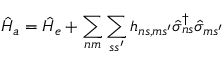Convert formula to latex. <formula><loc_0><loc_0><loc_500><loc_500>\hat { H } _ { a } = \hat { H } _ { e } + \sum _ { n m } \sum _ { s s ^ { \prime } } h _ { n s , m s ^ { \prime } } \hat { \sigma } _ { n s } ^ { \dagger } \hat { \sigma } _ { m s ^ { \prime } }</formula> 